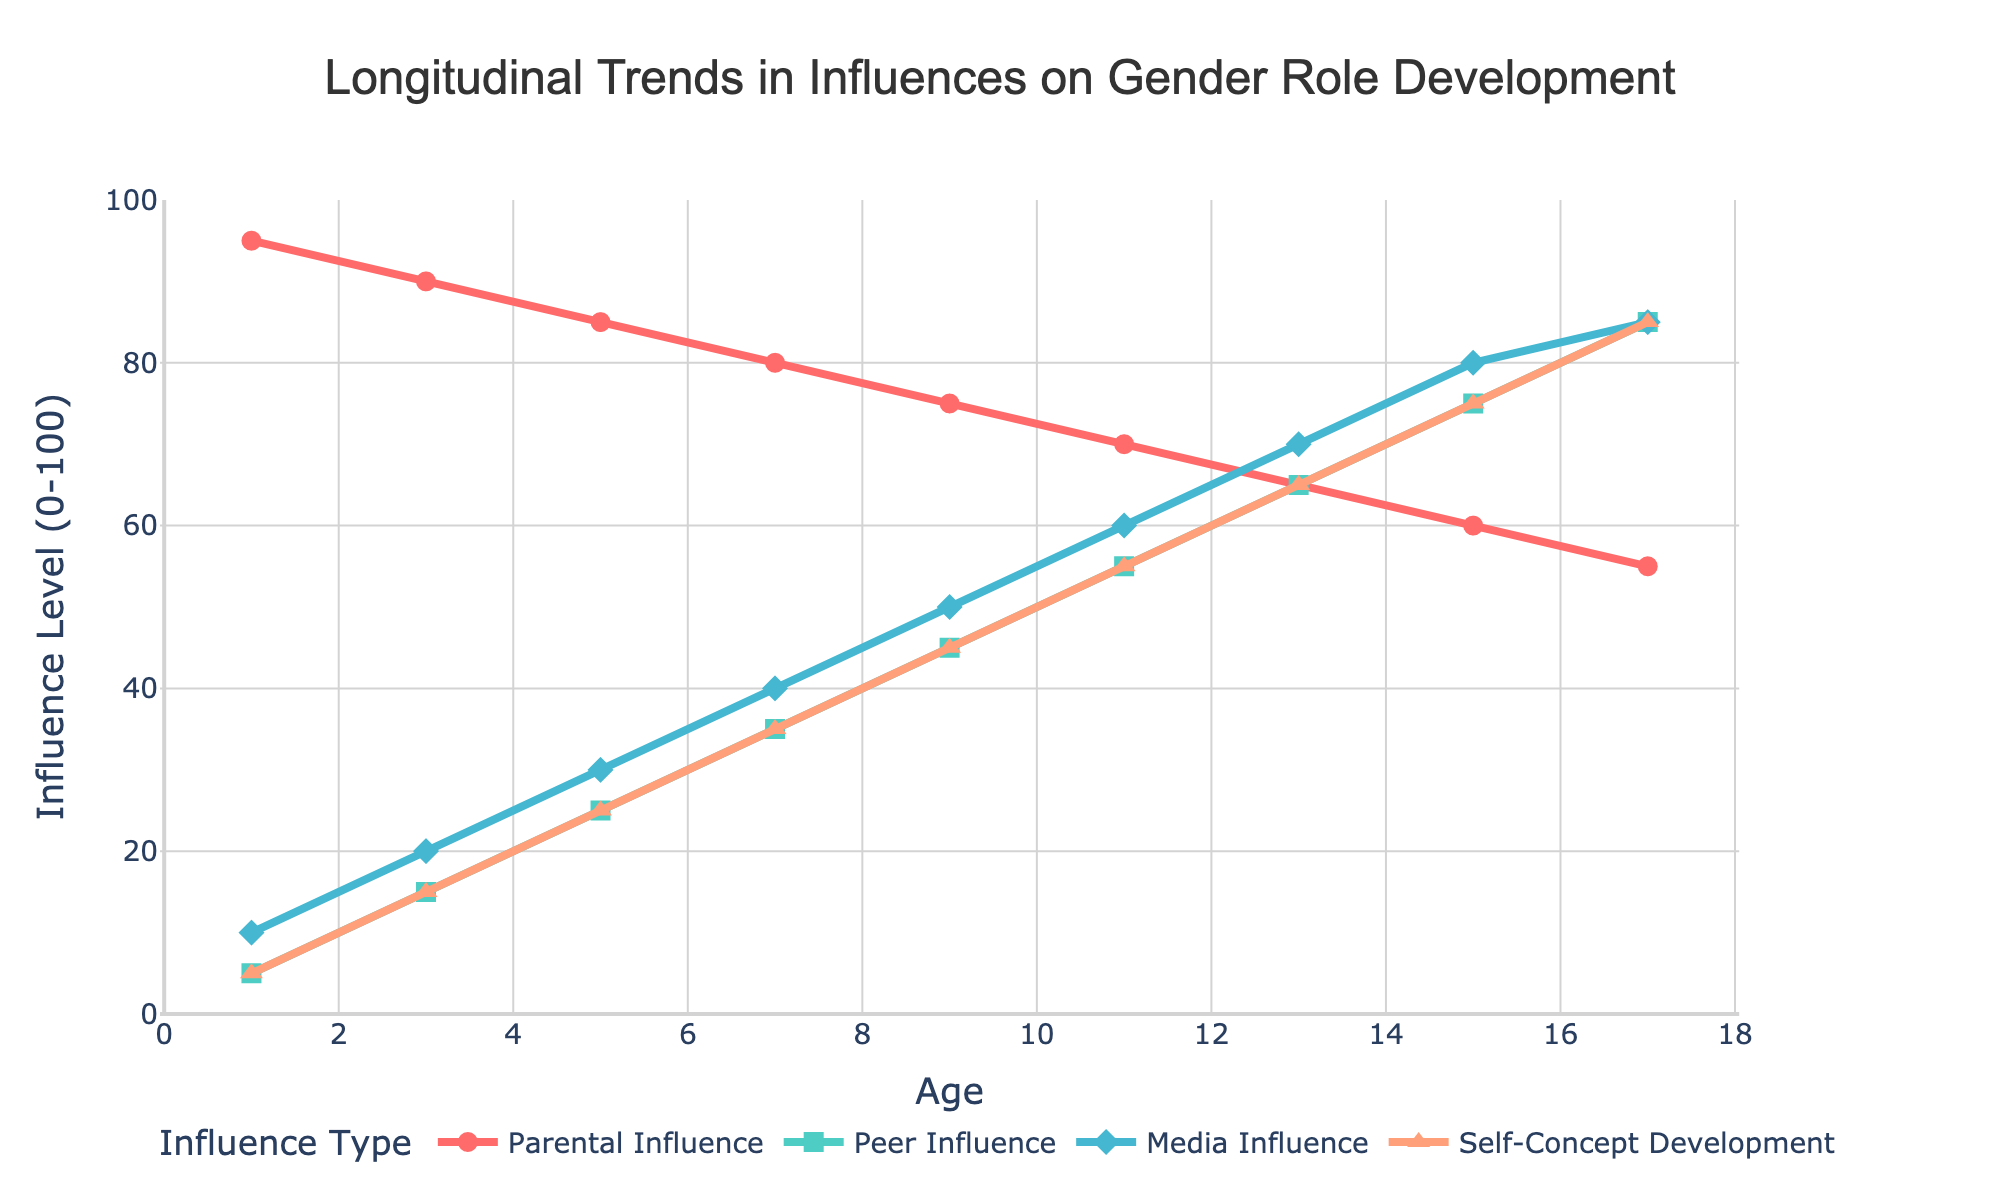What is the trend in Parental Influence from age 1 to age 17? The Parental Influence starts at 95 at age 1 and decreases steadily over time, reaching 55 at age 17.
Answer: Decreasing Which influence type has the highest value at age 9? At age 9, the values are Parental Influence: 75, Peer Influence: 45, Media Influence: 50, Self-Concept Development: 45. Thus, Parental Influence is the highest.
Answer: Parental Influence What is the average Peer Influence across all ages? Sum the Peer Influence values (5 + 15 + 25 + 35 + 45 + 55 + 65 + 75 + 85), which is 405, and then divide by the number of ages (9). 405 / 9 = 45.
Answer: 45 At what age does Self-Concept Development first intersect Peer Influence? The first intersection occurs at age 15 where both Peer Influence and Self-Concept Development are 75.
Answer: 15 How does Media Influence change relative to Parental Influence from age 1 to age 17? Media Influence starts lower than Parental Influence at age 1 (10 vs 95) and gradually increases while Parental Influence decreases. By age 17, Media Influence reaches 85, almost equal to Parental Influence which is 55.
Answer: Increases Which age group shows the least difference between Media Influence and Self-Concept Development? Calculate the differences: at age 1: 5, at age 3: 5, at age 5: 5, at age 7: 5, at age 9: 5, at age 11: 5, at age 13: 5, at age 15: 5, at age 17: 0. Age 17 has the least difference (0).
Answer: 17 What is the combined influence of peers and media at age 11? Peer Influence at age 11 is 55 and Media Influence is 60. Sum these values: 55 + 60 = 115.
Answer: 115 